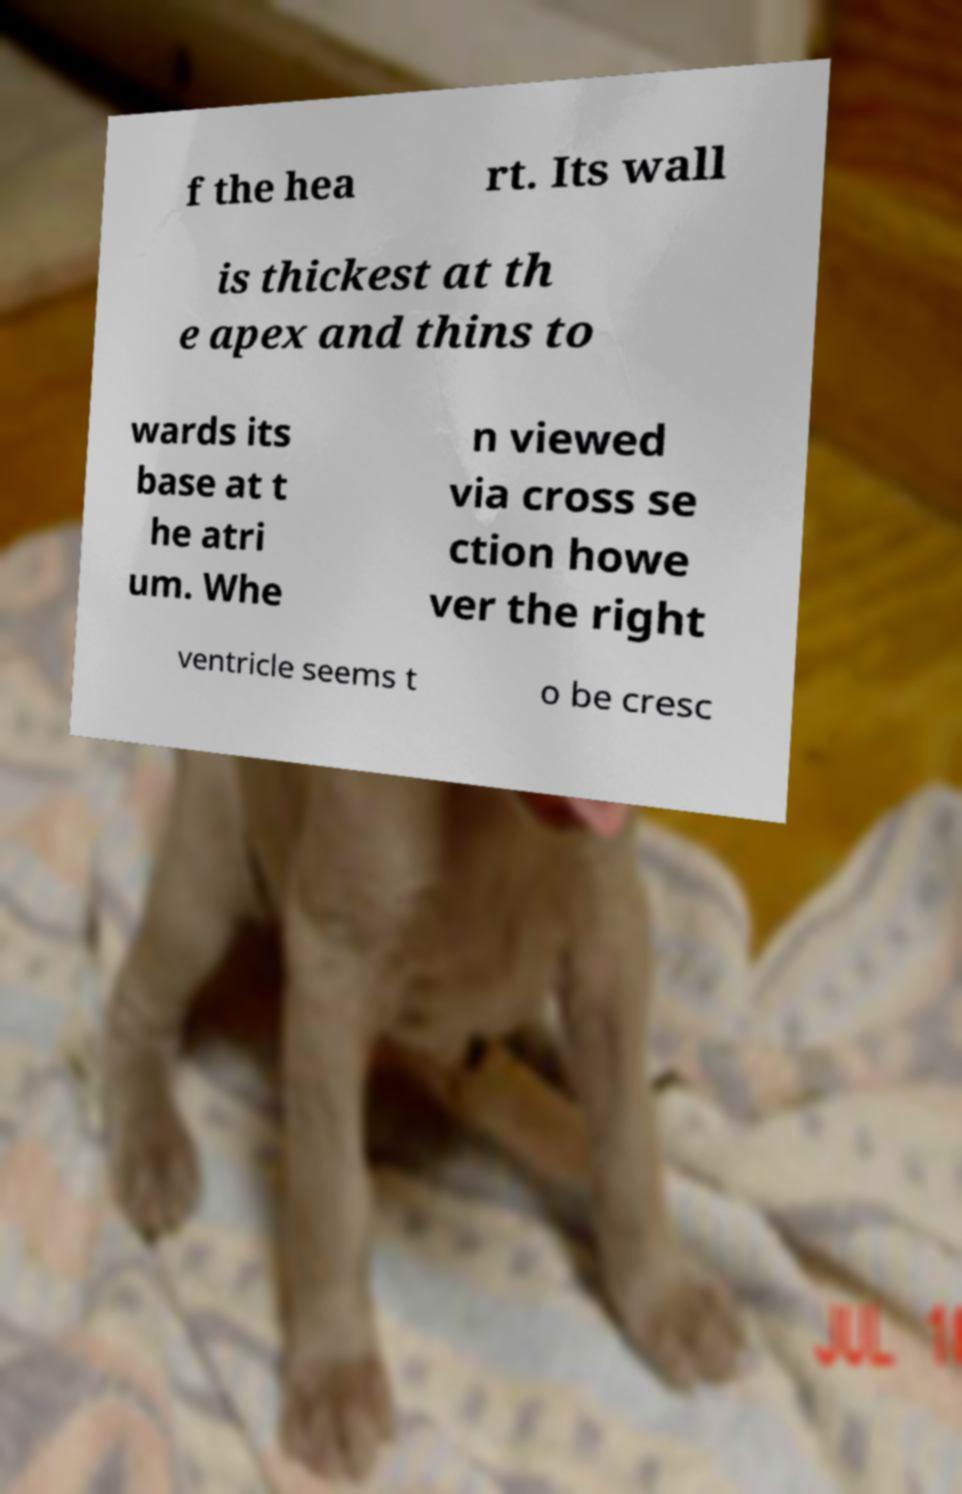Please read and relay the text visible in this image. What does it say? f the hea rt. Its wall is thickest at th e apex and thins to wards its base at t he atri um. Whe n viewed via cross se ction howe ver the right ventricle seems t o be cresc 